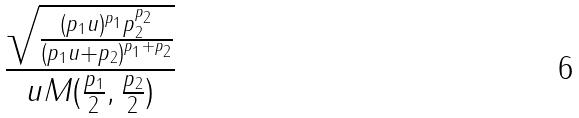<formula> <loc_0><loc_0><loc_500><loc_500>\frac { \sqrt { \frac { ( p _ { 1 } u ) ^ { p _ { 1 } } p _ { 2 } ^ { p _ { 2 } } } { ( p _ { 1 } u + p _ { 2 } ) ^ { p _ { 1 } + p _ { 2 } } } } } { u M ( \frac { p _ { 1 } } { 2 } , \frac { p _ { 2 } } { 2 } ) }</formula> 